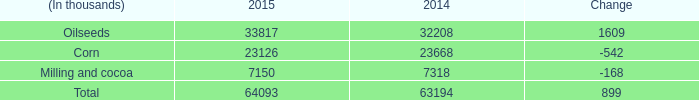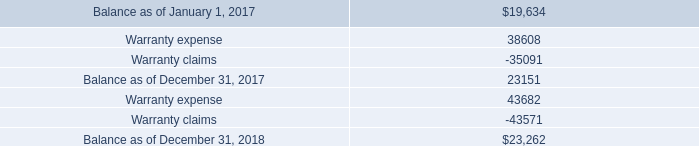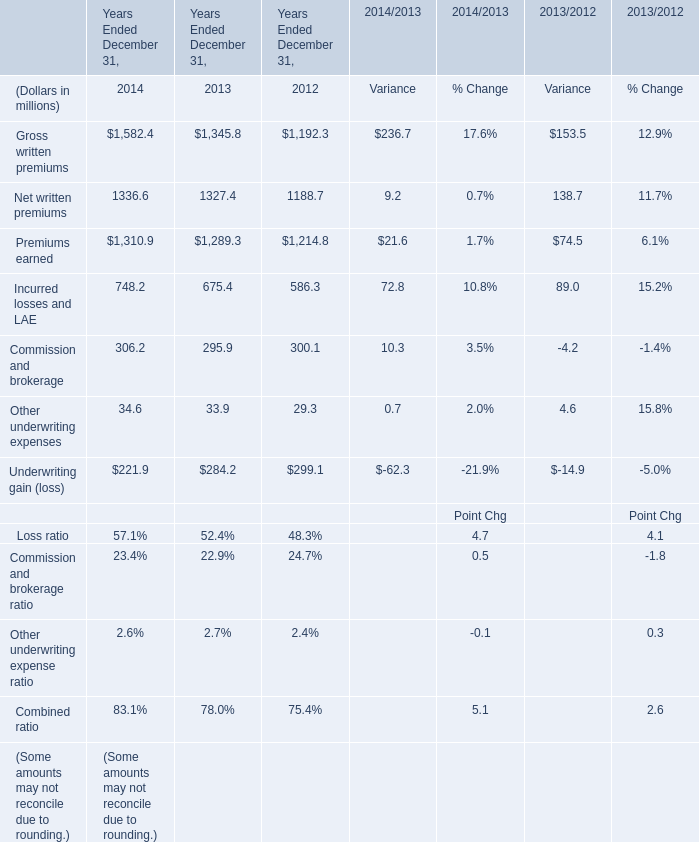What is the sum of Balance as of December 31, 2018, and Gross written premiums of Years Ended December 31, 2012 ? 
Computations: (23262.0 + 1192.3)
Answer: 24454.3. 